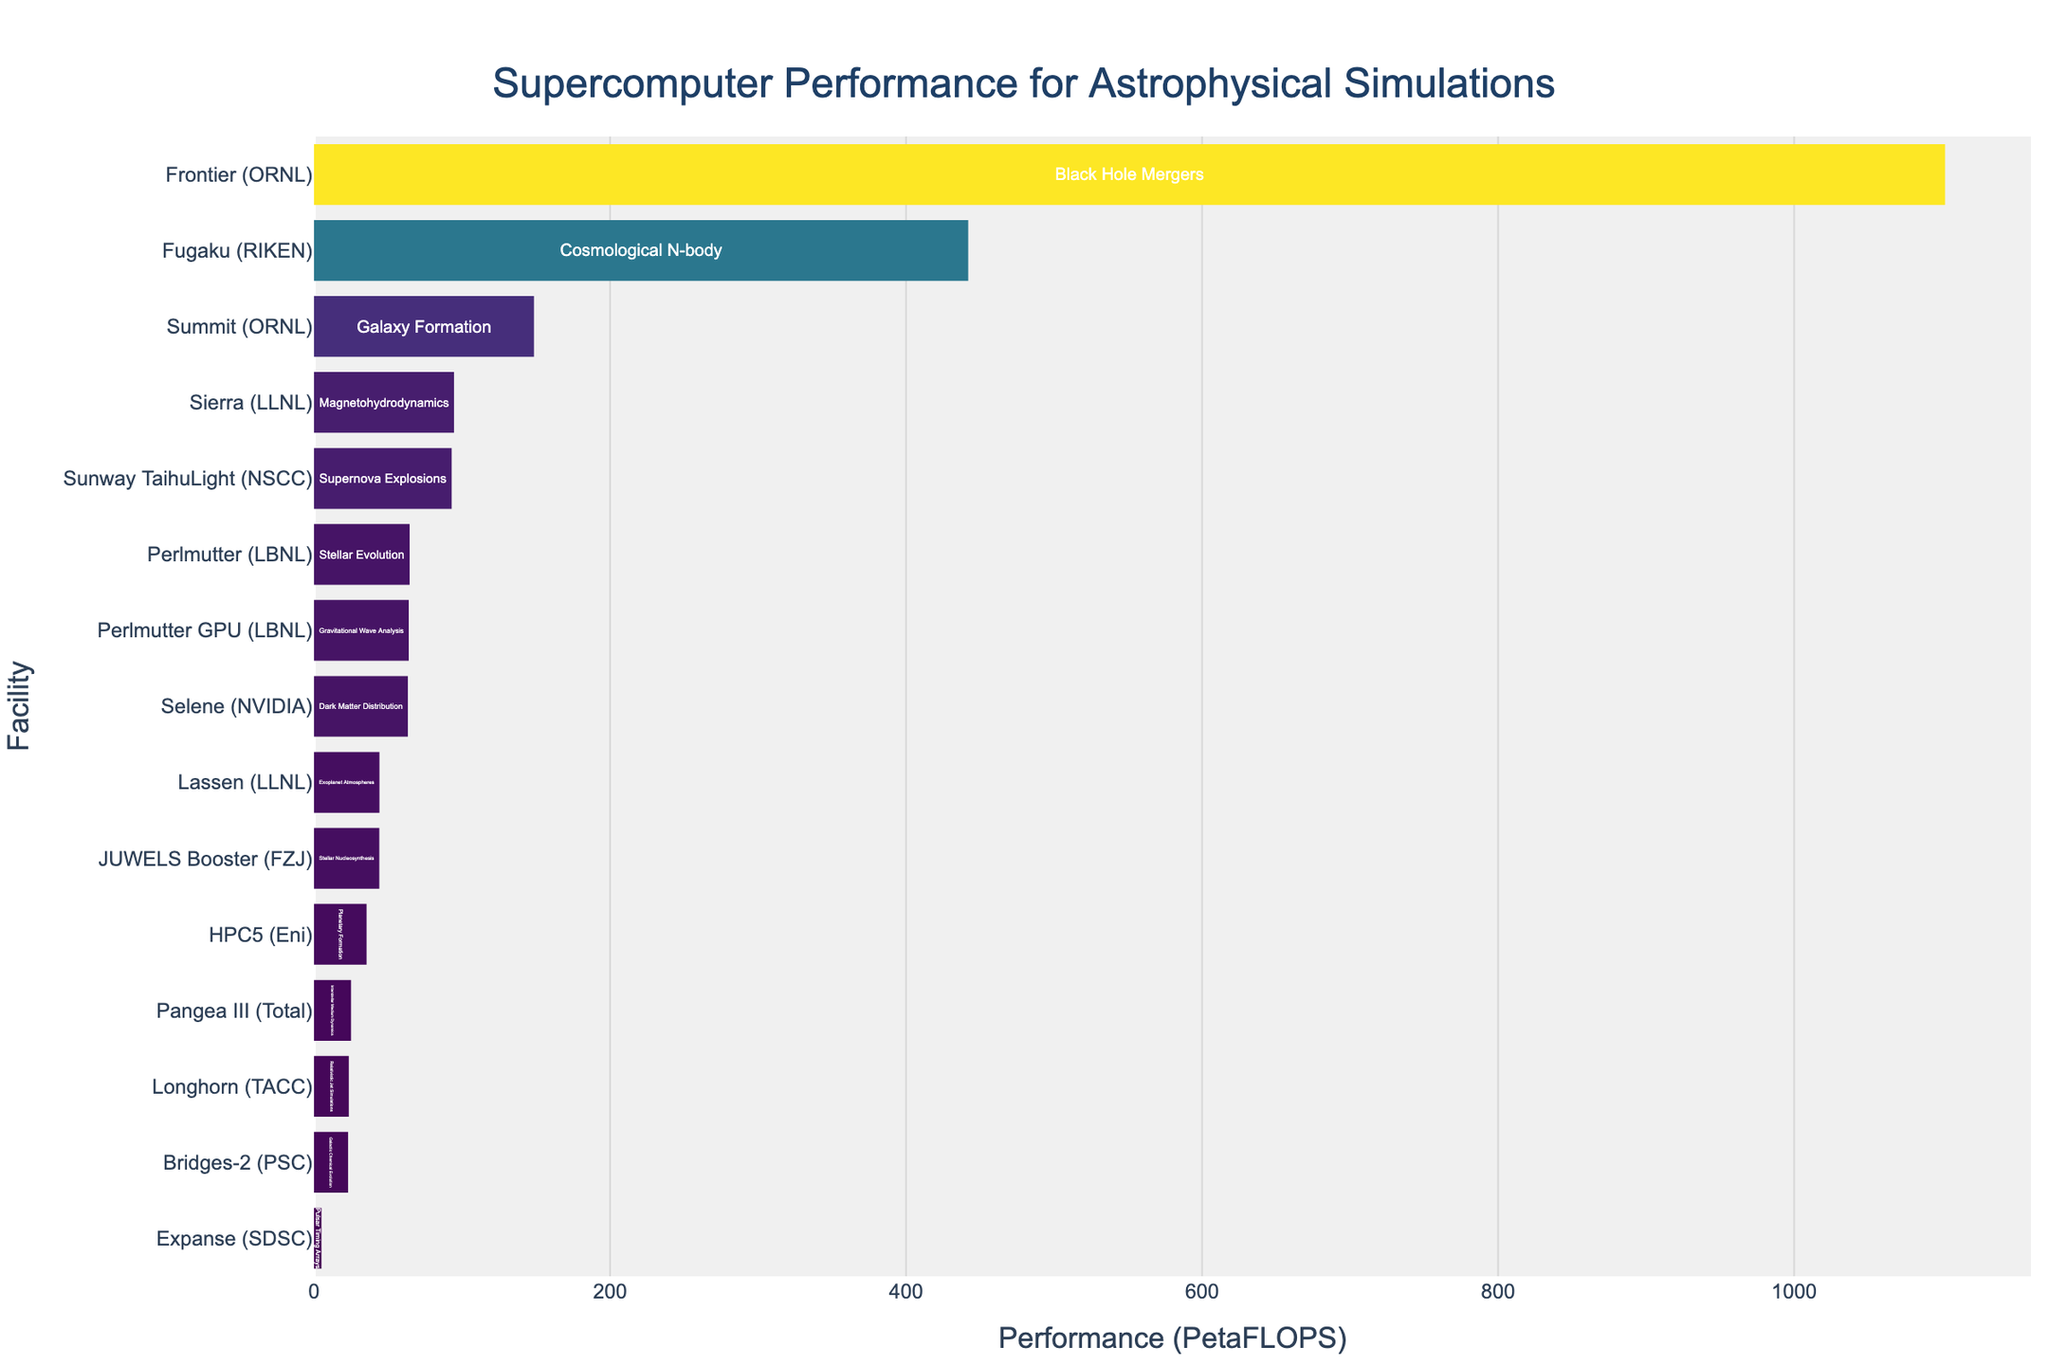Which facility has the highest performance for astrophysical simulations? The facility with the highest performance is the one with the longest bar in the bar chart. In the figure, Frontier (ORNL) has the longest bar, indicating the highest performance.
Answer: Frontier (ORNL) What is the combined performance of Fugaku and Summit? We need to add the performance values for Fugaku and Summit. According to the figure, Fugaku has a performance of 442.0 PetaFLOPS and Summit has 148.6 PetaFLOPS. Adding these together gives 442.0 + 148.6.
Answer: 590.6 Which facilities are used for simulations of black hole mergers and supernova explosions? From the bars labeled by simulation types in the figure, the facility for black hole mergers is marked for Frontier (ORNL), and the facility for supernova explosions is marked for Sunway TaihuLight (NSCC).
Answer: Frontier (ORNL) and Sunway TaihuLight (NSCC) Is the performance of Perlmutter higher or lower than Sierra? Comparing the lengths of the bars for Perlmutter and Sierra, Perlmutter has a performance of 64.6 PetaFLOPS and Sierra has a performance of 94.6 PetaFLOPS. Sierra's bar is longer, indicating higher performance.
Answer: Lower Arrange the facilities performing stellar evolution and stellar nucleosynthesis in ascending order of performance. The facilities listed for these simulations are Perlmutter (LBNL) for stellar evolution with 64.6 PetaFLOPS and JUWELS Booster (FZJ) for stellar nucleosynthesis with 44.1 PetaFLOPS. Arranging them in ascending order of performance gives JUWELS Booster first, then Perlmutter.
Answer: JUWELS Booster (FZJ), Perlmutter (LBNL) What is the average performance of the three lowest-performing facilities? The lowest-performing facilities are Expanse (SDSC) with 5.0 PetaFLOPS, Bridges-2 (PSC) with 23.0 PetaFLOPS, and Longhorn (TACC) with 23.5 PetaFLOPS. The average is calculated as (5.0 + 23.0 + 23.5) / 3.
Answer: 17.17 Which simulation type does the facility with the median performance conduct? To find the median, we'll list all performances in ascending order: 5.0, 23.0, 23.5, 25.0, 35.5, 44.1, 44.2, 63.4, 64.0, 64.6, 93.0, 94.6, 148.6, 442.0, 1102.0. The middle value is the 8th value, which is 63.4 PetaFLOPS at Selene (NVIDIA), conducting dark matter distribution simulations.
Answer: Dark Matter Distribution 